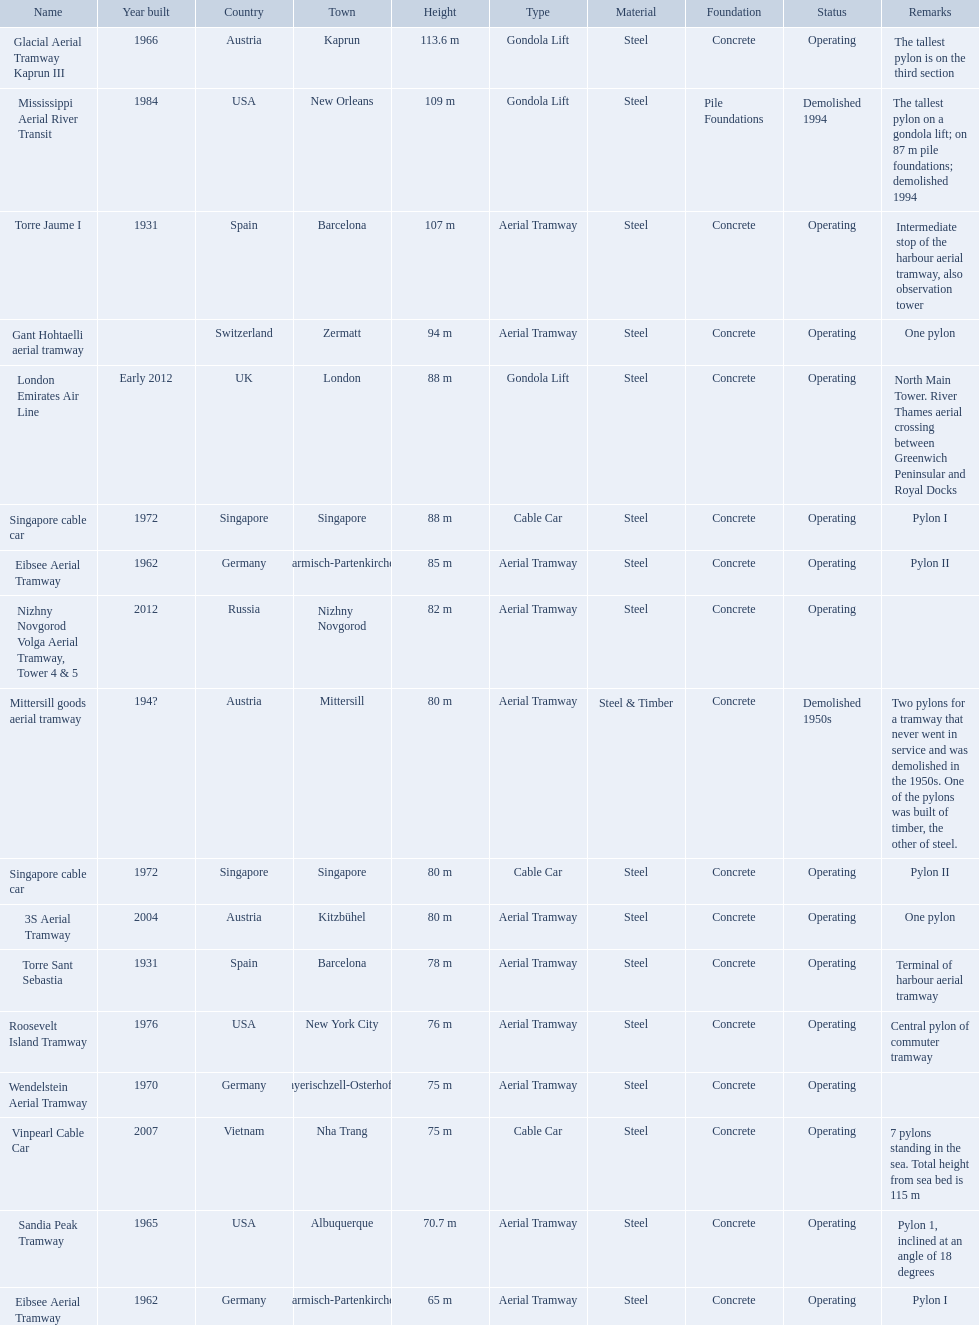Which lift has the second highest height? Mississippi Aerial River Transit. What is the value of the height? 109 m. 